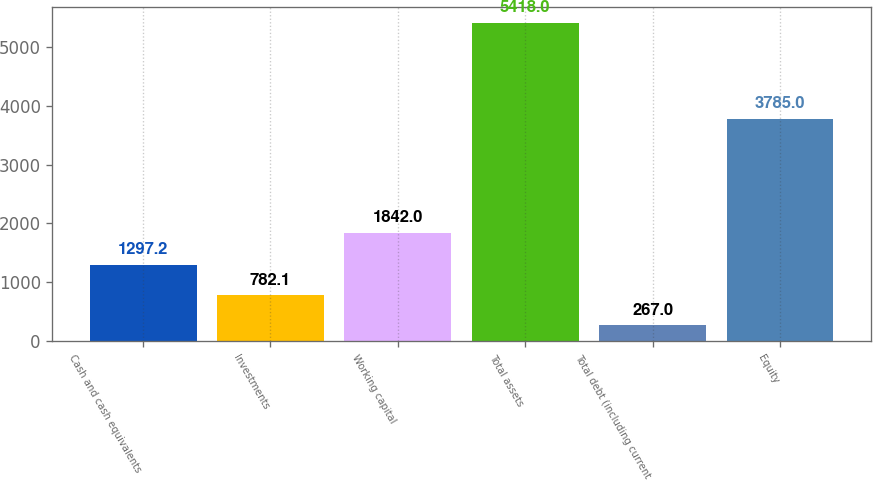Convert chart to OTSL. <chart><loc_0><loc_0><loc_500><loc_500><bar_chart><fcel>Cash and cash equivalents<fcel>Investments<fcel>Working capital<fcel>Total assets<fcel>Total debt (including current<fcel>Equity<nl><fcel>1297.2<fcel>782.1<fcel>1842<fcel>5418<fcel>267<fcel>3785<nl></chart> 